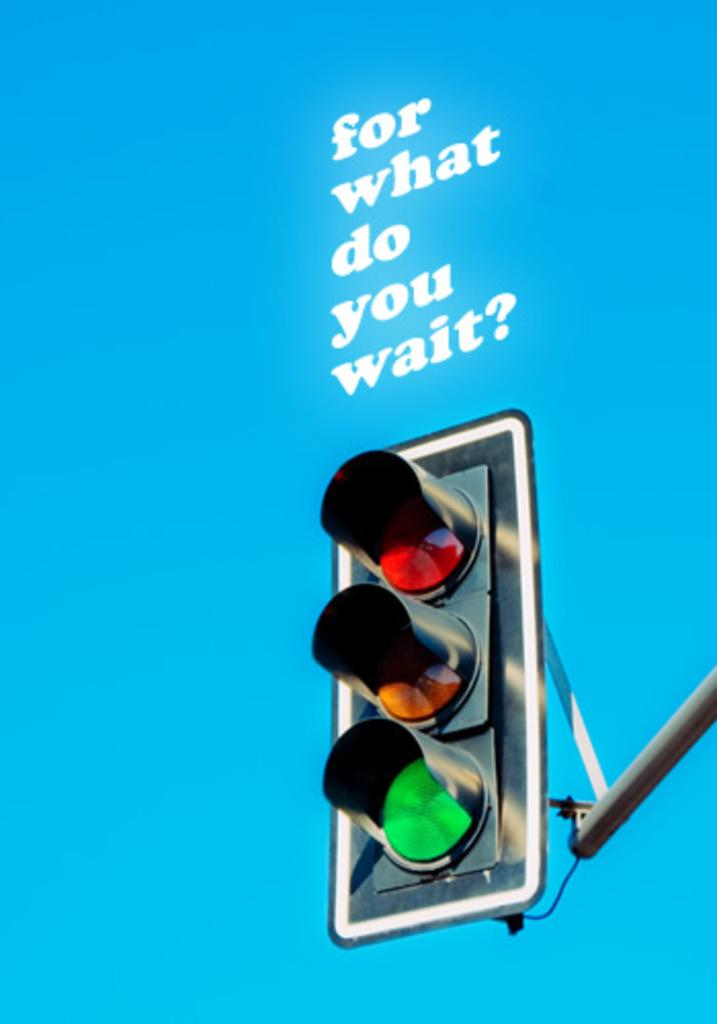<image>
Share a concise interpretation of the image provided. A quote above a stop light says "for what do you wait?" 